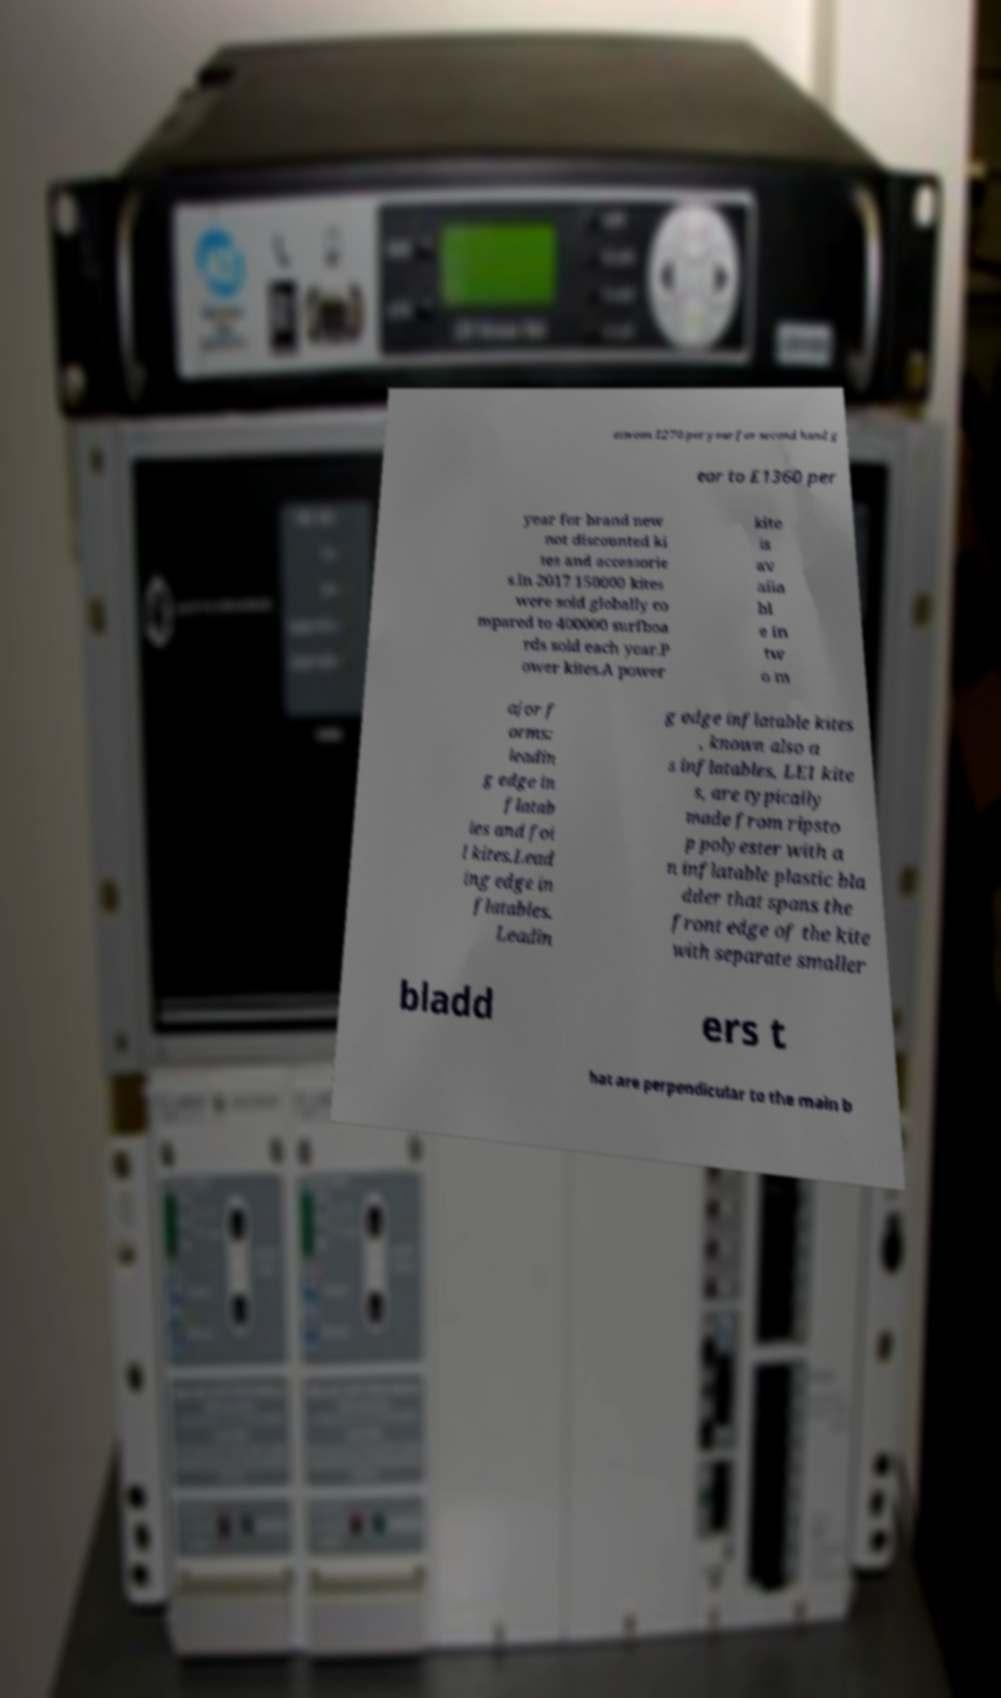I need the written content from this picture converted into text. Can you do that? etween £270 per year for second hand g ear to £1360 per year for brand new not discounted ki tes and accessorie s.In 2017 150000 kites were sold globally co mpared to 400000 surfboa rds sold each year.P ower kites.A power kite is av aila bl e in tw o m ajor f orms: leadin g edge in flatab les and foi l kites.Lead ing edge in flatables. Leadin g edge inflatable kites , known also a s inflatables, LEI kite s, are typically made from ripsto p polyester with a n inflatable plastic bla dder that spans the front edge of the kite with separate smaller bladd ers t hat are perpendicular to the main b 